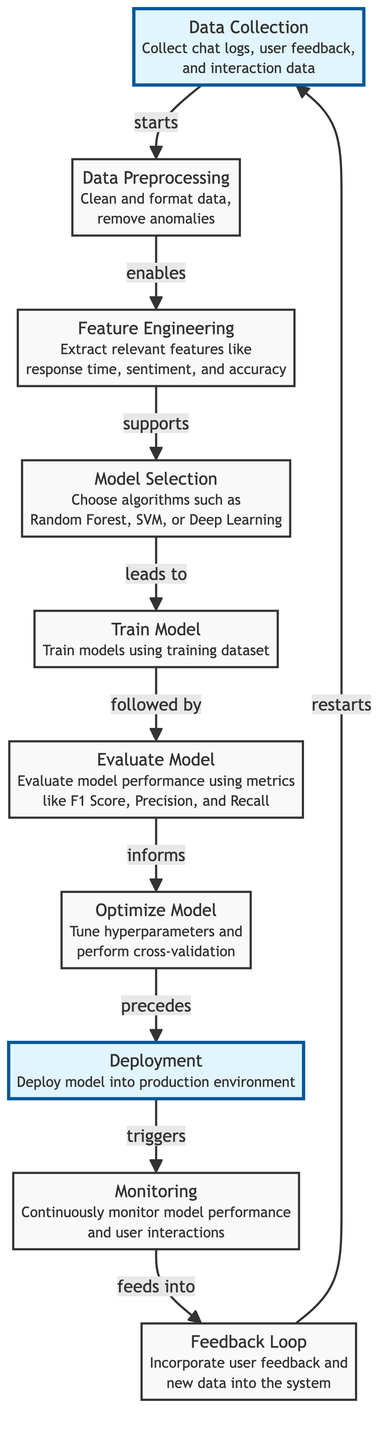What is the starting point of the flowchart? The starting point of the flowchart is the "Data Collection" node, which initiates the process by collecting necessary data.
Answer: Data Collection How many nodes are there in total? The diagram contains a total of 9 nodes representing different steps in the machine learning process.
Answer: 9 What is the relationship between "Evaluate Model" and "Optimize Model"? The relationship indicates that the "Evaluate Model" step informs the "Optimize Model" step, meaning the evaluation results guide the optimization process.
Answer: informs Which node follows "Train Model"? The node that follows "Train Model" is the "Evaluate Model," indicating the next step in the flow after training.
Answer: Evaluate Model What does the "Monitoring" node feed into? The "Monitoring" node feeds into the "Feedback Loop," showing how performance data continues to inform the model improvement cycle.
Answer: feedback loop Which nodes are highlighted in the diagram? The highlighted nodes in the diagram are "Data Collection" and "Deployment," indicating their significance in the process.
Answer: Data Collection, Deployment What is the final step that leads back to the starting point? The final step in the flow that leads back to the starting point is the "Feedback Loop," which incorporates new data and feedback into the system.
Answer: Feedback Loop What step precedes "Deployment"? The step that precedes "Deployment" is "Optimize Model," indicating that optimization is completed before deploying the model.
Answer: Optimize Model Which algorithms can be chosen during "Model Selection"? During "Model Selection," algorithms like Random Forest, SVM, or Deep Learning can be selected based on the specific requirements of the analysis.
Answer: Random Forest, SVM, Deep Learning 